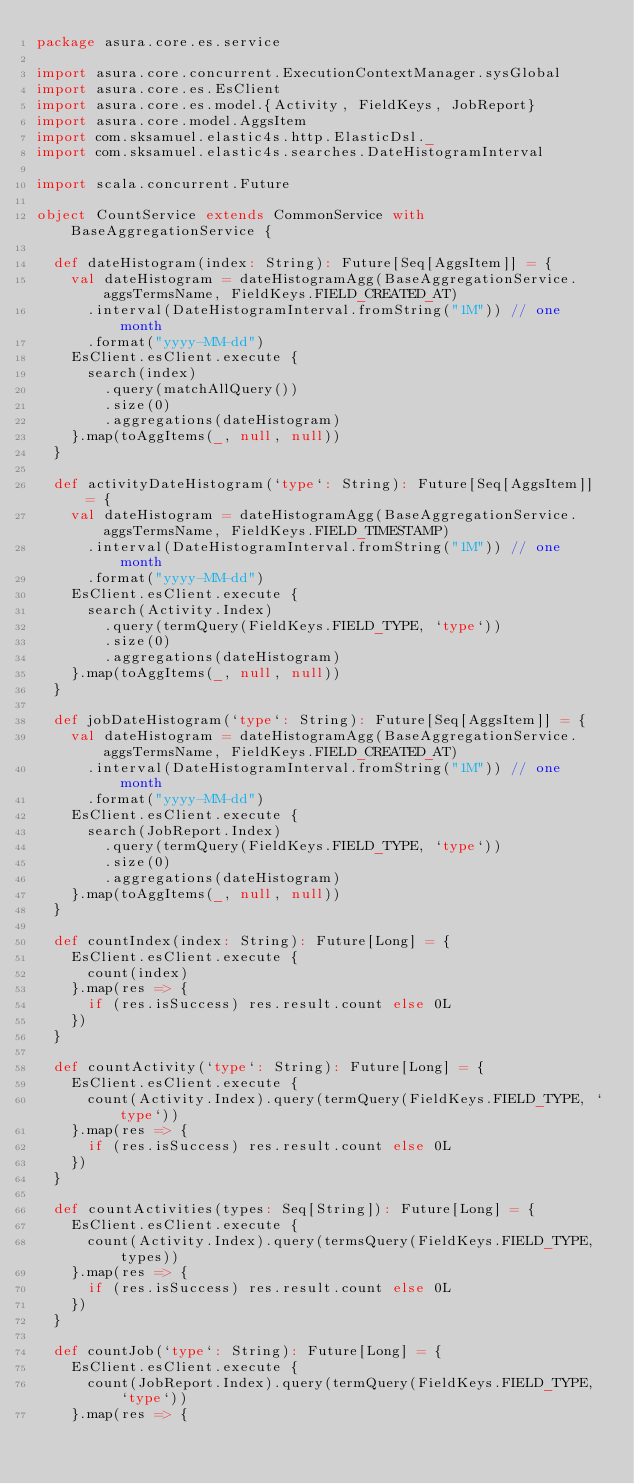<code> <loc_0><loc_0><loc_500><loc_500><_Scala_>package asura.core.es.service

import asura.core.concurrent.ExecutionContextManager.sysGlobal
import asura.core.es.EsClient
import asura.core.es.model.{Activity, FieldKeys, JobReport}
import asura.core.model.AggsItem
import com.sksamuel.elastic4s.http.ElasticDsl._
import com.sksamuel.elastic4s.searches.DateHistogramInterval

import scala.concurrent.Future

object CountService extends CommonService with BaseAggregationService {

  def dateHistogram(index: String): Future[Seq[AggsItem]] = {
    val dateHistogram = dateHistogramAgg(BaseAggregationService.aggsTermsName, FieldKeys.FIELD_CREATED_AT)
      .interval(DateHistogramInterval.fromString("1M")) // one month
      .format("yyyy-MM-dd")
    EsClient.esClient.execute {
      search(index)
        .query(matchAllQuery())
        .size(0)
        .aggregations(dateHistogram)
    }.map(toAggItems(_, null, null))
  }

  def activityDateHistogram(`type`: String): Future[Seq[AggsItem]] = {
    val dateHistogram = dateHistogramAgg(BaseAggregationService.aggsTermsName, FieldKeys.FIELD_TIMESTAMP)
      .interval(DateHistogramInterval.fromString("1M")) // one month
      .format("yyyy-MM-dd")
    EsClient.esClient.execute {
      search(Activity.Index)
        .query(termQuery(FieldKeys.FIELD_TYPE, `type`))
        .size(0)
        .aggregations(dateHistogram)
    }.map(toAggItems(_, null, null))
  }

  def jobDateHistogram(`type`: String): Future[Seq[AggsItem]] = {
    val dateHistogram = dateHistogramAgg(BaseAggregationService.aggsTermsName, FieldKeys.FIELD_CREATED_AT)
      .interval(DateHistogramInterval.fromString("1M")) // one month
      .format("yyyy-MM-dd")
    EsClient.esClient.execute {
      search(JobReport.Index)
        .query(termQuery(FieldKeys.FIELD_TYPE, `type`))
        .size(0)
        .aggregations(dateHistogram)
    }.map(toAggItems(_, null, null))
  }

  def countIndex(index: String): Future[Long] = {
    EsClient.esClient.execute {
      count(index)
    }.map(res => {
      if (res.isSuccess) res.result.count else 0L
    })
  }

  def countActivity(`type`: String): Future[Long] = {
    EsClient.esClient.execute {
      count(Activity.Index).query(termQuery(FieldKeys.FIELD_TYPE, `type`))
    }.map(res => {
      if (res.isSuccess) res.result.count else 0L
    })
  }

  def countActivities(types: Seq[String]): Future[Long] = {
    EsClient.esClient.execute {
      count(Activity.Index).query(termsQuery(FieldKeys.FIELD_TYPE, types))
    }.map(res => {
      if (res.isSuccess) res.result.count else 0L
    })
  }

  def countJob(`type`: String): Future[Long] = {
    EsClient.esClient.execute {
      count(JobReport.Index).query(termQuery(FieldKeys.FIELD_TYPE, `type`))
    }.map(res => {</code> 